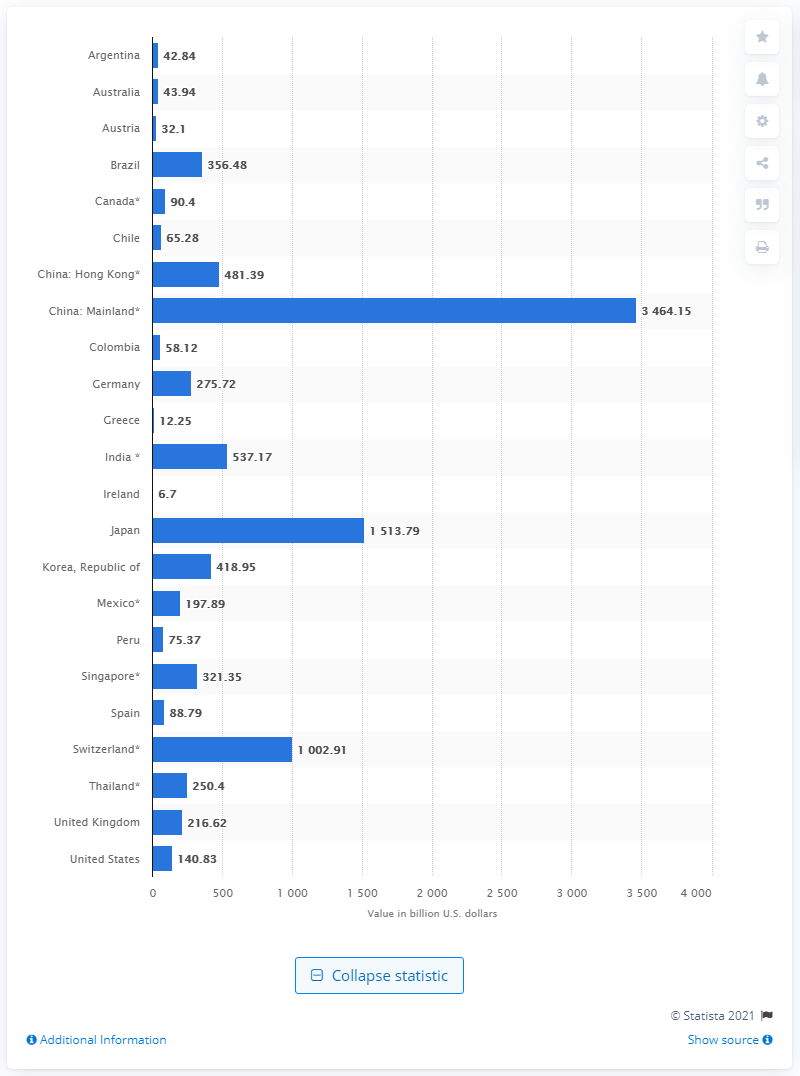Which countries have foreign-exchange reserves of less than 100 billion U.S. dollars according to the image? The countries with foreign-exchange reserves of less than 100 billion U.S. dollars, as indicated in the image, are Argentina, Austria, Chile, Colombia, Greece, Ireland, Peru, Spain, and Thailand. These countries' reserves range from Greece’s 12.25 billion to Spain’s 88.79 billion U.S. dollars.  Can you tell me which countries, besides China, have reserves exceeding 500 billion U.S. dollars? Yes, apart from China, there are two countries in the image with reserves exceeding 500 billion U.S. dollars: Japan, with about 1.514 trillion, and India, with 537.17 billion U.S. dollars. These substantial reserves reflect the size and strength of their respective economies. 